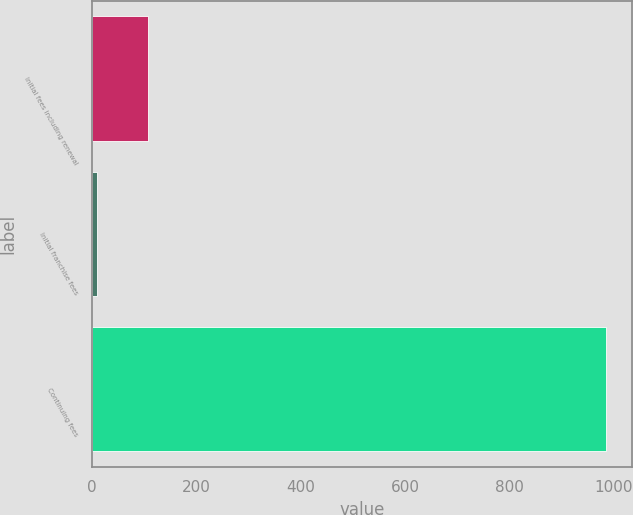<chart> <loc_0><loc_0><loc_500><loc_500><bar_chart><fcel>Initial fees including renewal<fcel>Initial franchise fees<fcel>Continuing fees<nl><fcel>107.6<fcel>10<fcel>986<nl></chart> 